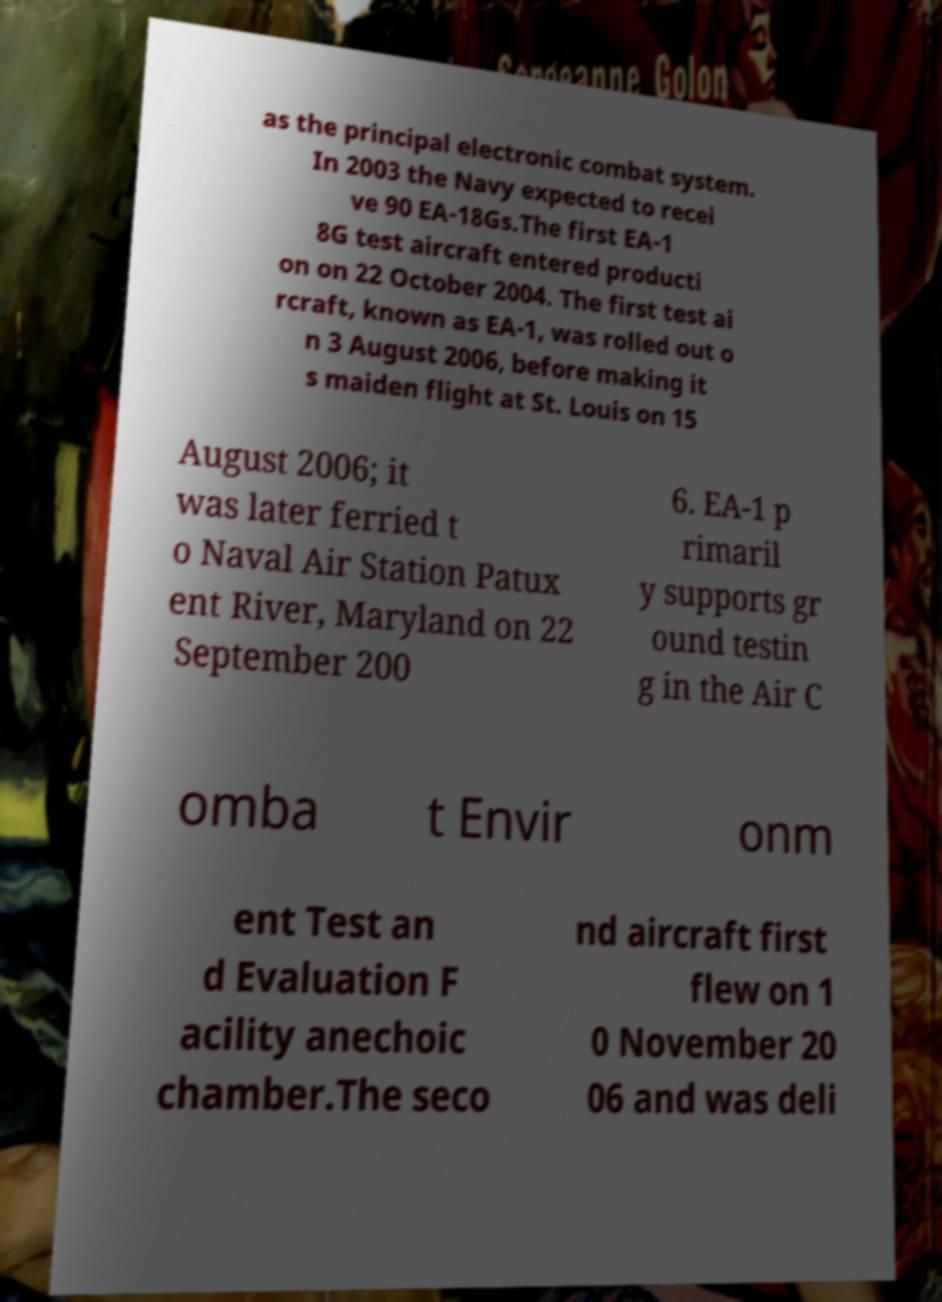Please read and relay the text visible in this image. What does it say? as the principal electronic combat system. In 2003 the Navy expected to recei ve 90 EA-18Gs.The first EA-1 8G test aircraft entered producti on on 22 October 2004. The first test ai rcraft, known as EA-1, was rolled out o n 3 August 2006, before making it s maiden flight at St. Louis on 15 August 2006; it was later ferried t o Naval Air Station Patux ent River, Maryland on 22 September 200 6. EA-1 p rimaril y supports gr ound testin g in the Air C omba t Envir onm ent Test an d Evaluation F acility anechoic chamber.The seco nd aircraft first flew on 1 0 November 20 06 and was deli 